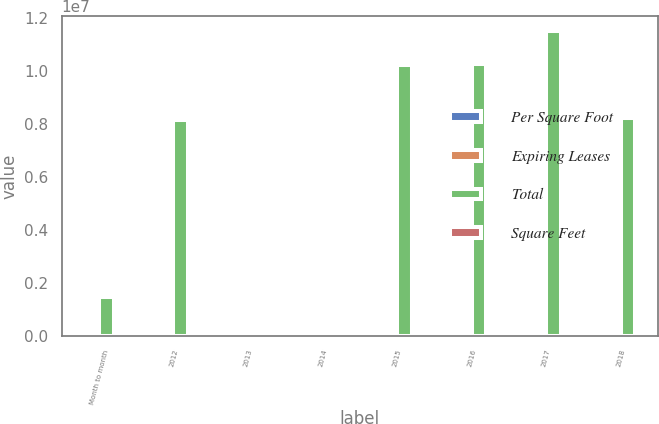Convert chart to OTSL. <chart><loc_0><loc_0><loc_500><loc_500><stacked_bar_chart><ecel><fcel>Month to month<fcel>2012<fcel>2013<fcel>2014<fcel>2015<fcel>2016<fcel>2017<fcel>2018<nl><fcel>Per Square Foot<fcel>17<fcel>78<fcel>120<fcel>133<fcel>99<fcel>79<fcel>45<fcel>33<nl><fcel>Expiring Leases<fcel>1.3<fcel>5.7<fcel>9.2<fcel>9.4<fcel>7<fcel>7.4<fcel>7.7<fcel>5.8<nl><fcel>Total<fcel>1.477e+06<fcel>8.16e+06<fcel>36.17<fcel>36.17<fcel>1.0254e+07<fcel>1.0268e+07<fcel>1.1516e+07<fcel>8.222e+06<nl><fcel>Square Feet<fcel>27.51<fcel>35.79<fcel>37.53<fcel>35.33<fcel>36.55<fcel>34.52<fcel>37.07<fcel>35.39<nl></chart> 